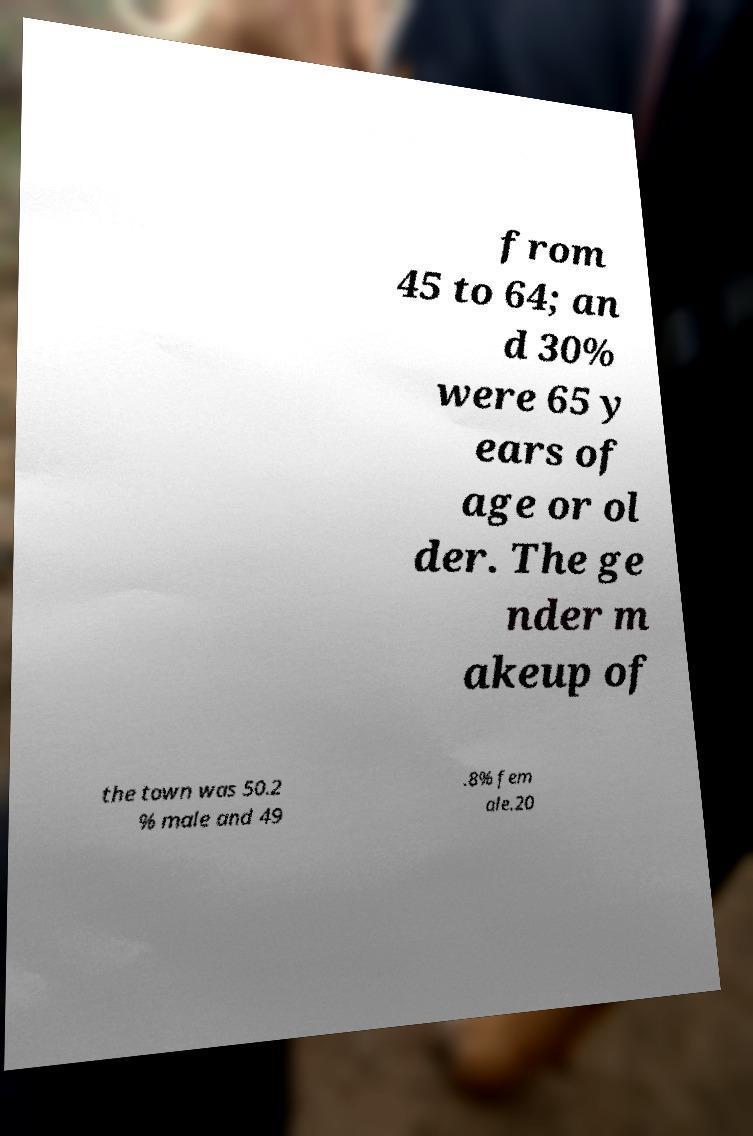I need the written content from this picture converted into text. Can you do that? from 45 to 64; an d 30% were 65 y ears of age or ol der. The ge nder m akeup of the town was 50.2 % male and 49 .8% fem ale.20 